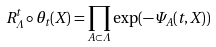Convert formula to latex. <formula><loc_0><loc_0><loc_500><loc_500>R ^ { t } _ { \Lambda } \circ \theta _ { t } ( X ) = \prod _ { A \subset \Lambda } \exp ( - \Psi _ { A } ( t , X ) )</formula> 